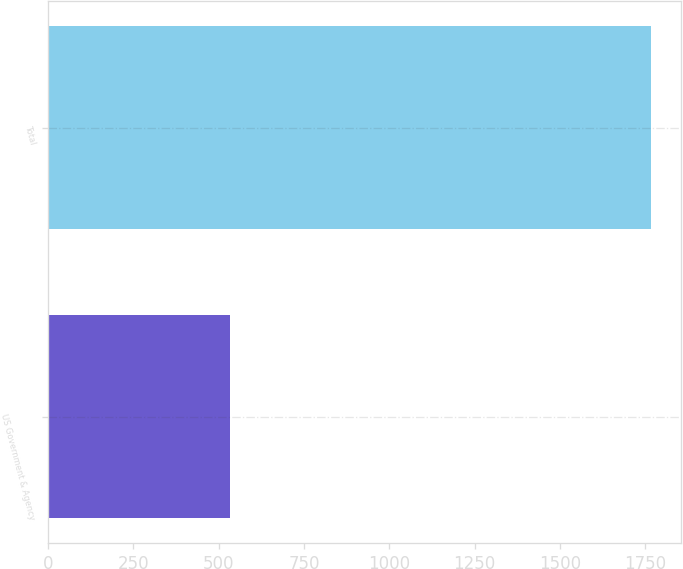Convert chart to OTSL. <chart><loc_0><loc_0><loc_500><loc_500><bar_chart><fcel>US Government & Agency<fcel>Total<nl><fcel>533<fcel>1766<nl></chart> 